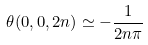<formula> <loc_0><loc_0><loc_500><loc_500>\theta ( 0 , 0 , 2 n ) \simeq - \frac { 1 } { 2 n \pi }</formula> 